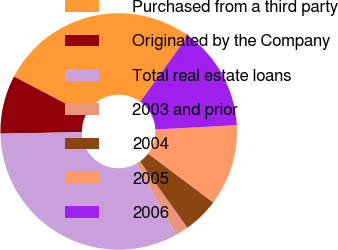Convert chart to OTSL. <chart><loc_0><loc_0><loc_500><loc_500><pie_chart><fcel>Purchased from a third party<fcel>Originated by the Company<fcel>Total real estate loans<fcel>2003 and prior<fcel>2004<fcel>2005<fcel>2006<nl><fcel>27.28%<fcel>7.99%<fcel>32.79%<fcel>1.79%<fcel>4.89%<fcel>11.09%<fcel>14.19%<nl></chart> 